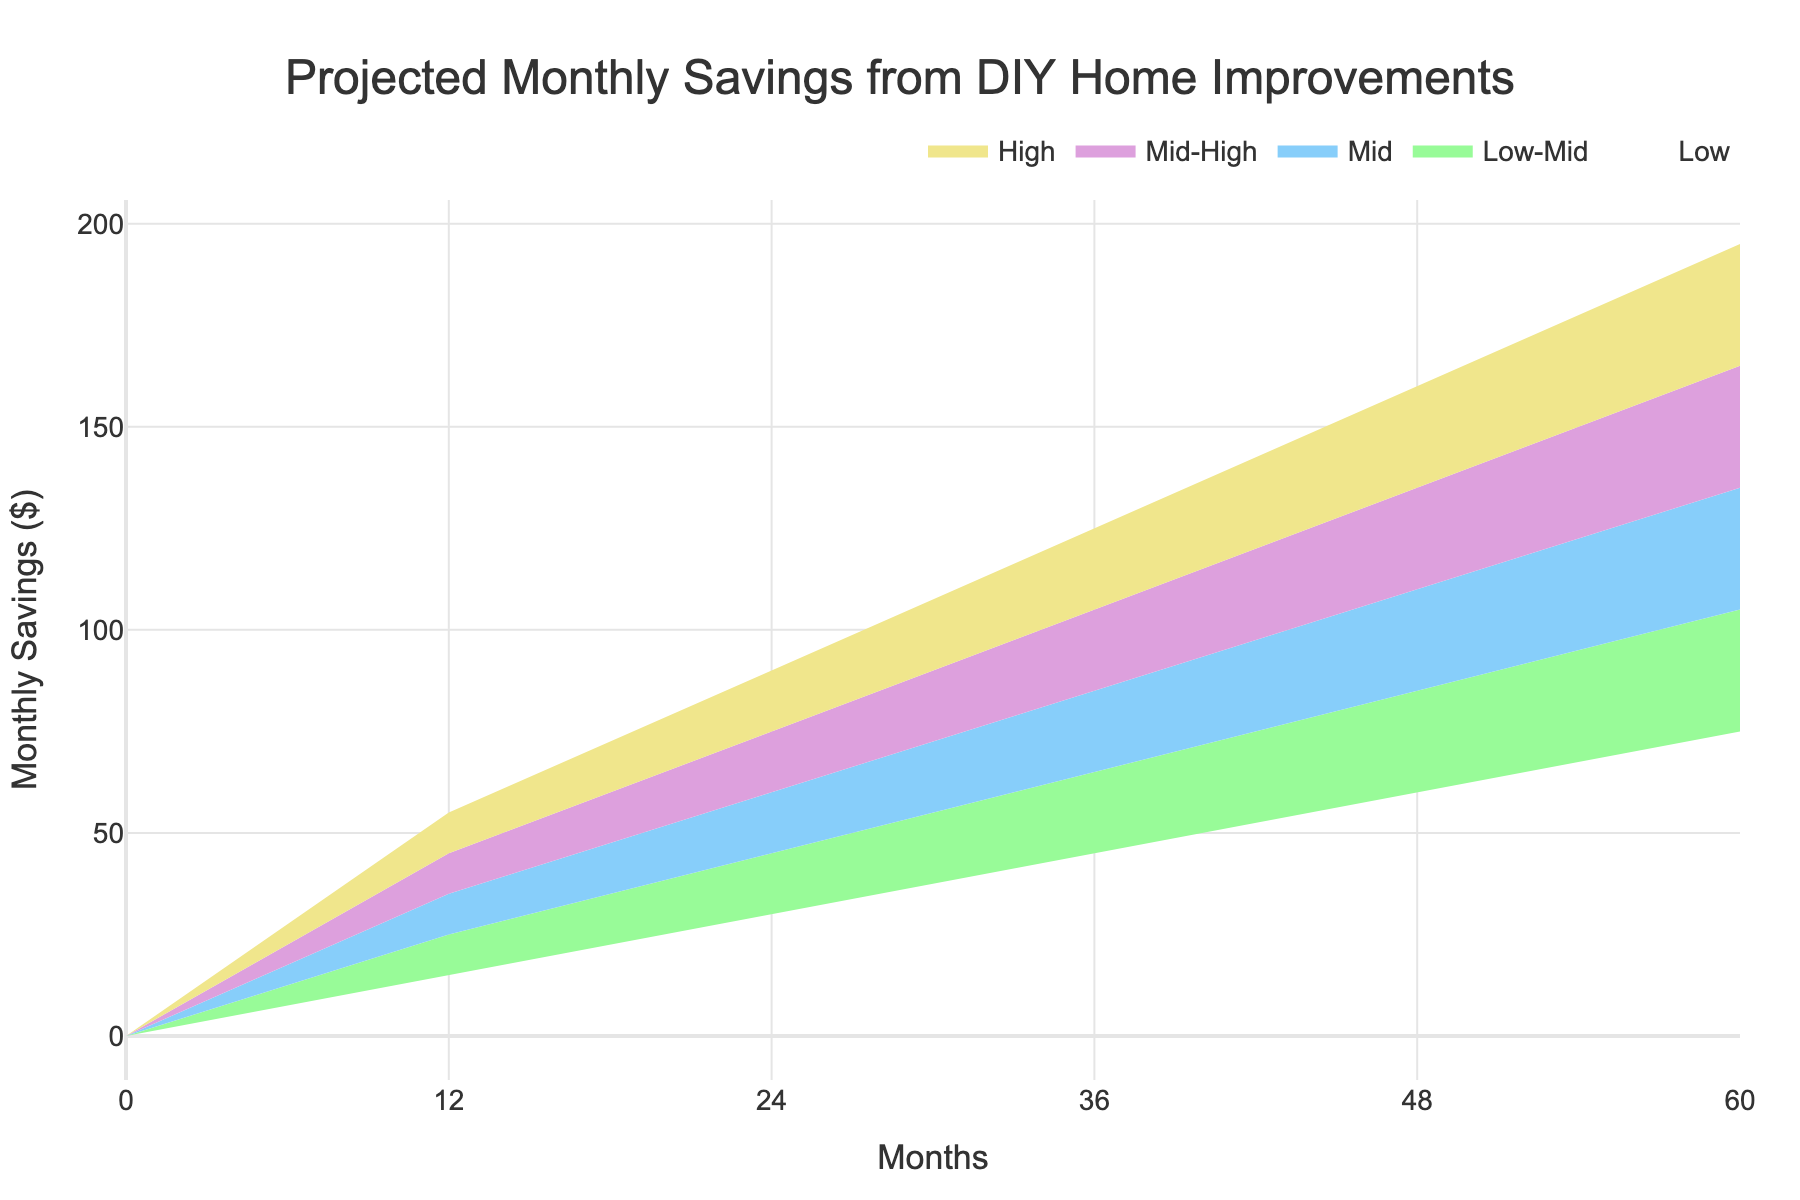What is the title of the figure? The title is typically located at the top of the figure and is visually distinct, often larger in font size. In this case, it is "Projected Monthly Savings from DIY Home Improvements."
Answer: Projected Monthly Savings from DIY Home Improvements What are the colors used in the chart? The colors can be observed directly from the figure. They are light shades used to differentiate the bands.
Answer: Light salmon, pale green, light blue, lavender, light yellow How many months are displayed in the x-axis of the figure? The x-axis shows the timeline, it starts at 0 and goes up to 60 months, with increments visible at every 12 months.
Answer: 6 What is the range of the projected monthly savings at the end of 5 years for the 'High' category? At the end of 60 months, check the value at 60 under the 'High' column, which represents the upper bound of the projection for the 'High' category.
Answer: $195 How do the projected monthly savings for the 'Mid' and 'Low-Mid' categories compare at 36 months? At the 36-month mark, observe the respective values under the 'Mid' and 'Low-Mid' columns to see which one is higher and by how much.
Answer: Mid is 85, Low-Mid is 65 What is the difference in projected savings between the 'Low' and 'High' categories at 24 months? At the 24-month mark, subtract the value in the 'Low' category from the value in the 'High' category to get the difference. High is 90, Low is 30 => 90 - 30.
Answer: $60 What is the average projected savings for the 'Mid' category over the 60 months? Sum the values in the 'Mid' column and divide by the number of data points (6: one for each 12-month increment). (0 + 35 + 60 + 85 + 110 + 135) / 6
Answer: $70.83 Which category shows a more significant increase in savings from month 0 to month 60? Calculate the increase for each category by subtracting the initial value at month 0 from the final value at month 60, then identify the category with the largest increase. High: 195 - 0 = 195, Mid: 135 - 0 = 135, etc.
Answer: High Does the savings projection for the 'Low-Mid' category ever surpass the 'Mid-High' category? Compare the values in 'Low-Mid' and 'Mid-High' categories across all months to check if 'Low-Mid' is ever greater than 'Mid-High'.
Answer: No How much does the 'Mid' category increase in savings from month 12 to month 48? Find the values in the 'Mid' column at month 12 and month 48, then subtract the savings at month 12 from the savings at month 48. (110 - 35).
Answer: $75 